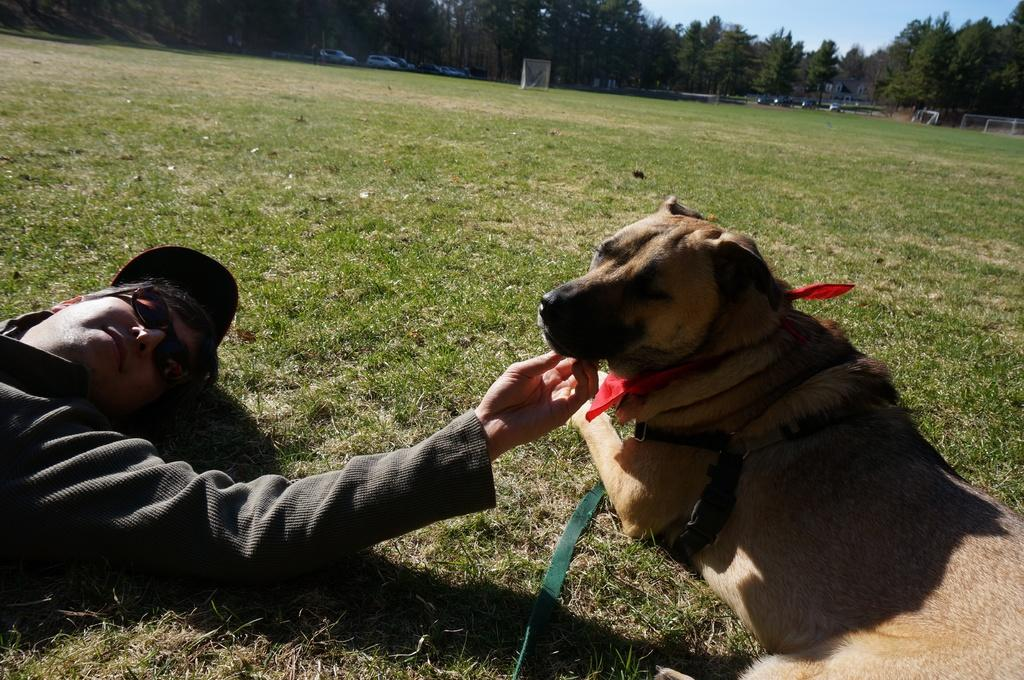What is the man in the image doing? The man is lying on the grass in the image. What is near the man? There is a dog beside the man in the image. What can be seen in the background of the image? There are vehicles and trees in the background of the image, as well as the sky. How many bears are visible in the image? There are no bears present in the image. What type of structure can be seen in the background of the image? There is no specific structure mentioned in the provided facts; the image only shows vehicles, trees, and the sky in the background. 